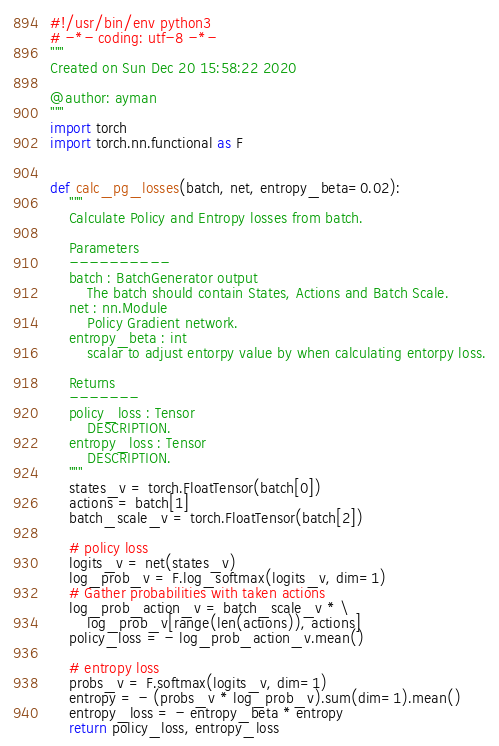<code> <loc_0><loc_0><loc_500><loc_500><_Python_>#!/usr/bin/env python3
# -*- coding: utf-8 -*-
"""
Created on Sun Dec 20 15:58:22 2020

@author: ayman
"""
import torch
import torch.nn.functional as F


def calc_pg_losses(batch, net, entropy_beta=0.02):
    """
    Calculate Policy and Entropy losses from batch.

    Parameters
    ----------
    batch : BatchGenerator output
        The batch should contain States, Actions and Batch Scale.
    net : nn.Module
        Policy Gradient network.
    entropy_beta : int
        scalar to adjust entorpy value by when calculating entorpy loss.

    Returns
    -------
    policy_loss : Tensor
        DESCRIPTION.
    entropy_loss : Tensor
        DESCRIPTION.
    """
    states_v = torch.FloatTensor(batch[0])
    actions = batch[1]
    batch_scale_v = torch.FloatTensor(batch[2])

    # policy loss
    logits_v = net(states_v)
    log_prob_v = F.log_softmax(logits_v, dim=1)
    # Gather probabilities with taken actions
    log_prob_action_v = batch_scale_v * \
        log_prob_v[range(len(actions)), actions]
    policy_loss = - log_prob_action_v.mean()

    # entropy loss
    probs_v = F.softmax(logits_v, dim=1)
    entropy = - (probs_v * log_prob_v).sum(dim=1).mean()
    entropy_loss = - entropy_beta * entropy
    return policy_loss, entropy_loss
</code> 